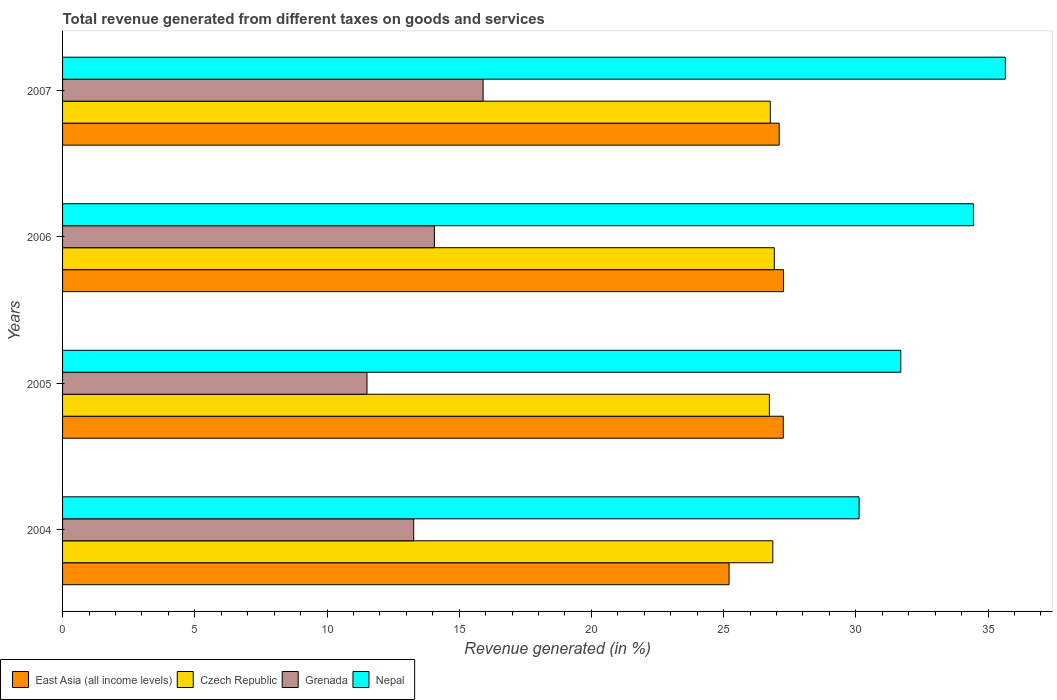Are the number of bars per tick equal to the number of legend labels?
Your answer should be compact. Yes. How many bars are there on the 3rd tick from the bottom?
Your answer should be compact. 4. What is the label of the 3rd group of bars from the top?
Ensure brevity in your answer.  2005. In how many cases, is the number of bars for a given year not equal to the number of legend labels?
Ensure brevity in your answer.  0. What is the total revenue generated in East Asia (all income levels) in 2006?
Your response must be concise. 27.26. Across all years, what is the maximum total revenue generated in East Asia (all income levels)?
Your answer should be compact. 27.26. Across all years, what is the minimum total revenue generated in Czech Republic?
Provide a succinct answer. 26.73. In which year was the total revenue generated in Grenada minimum?
Provide a short and direct response. 2005. What is the total total revenue generated in Grenada in the graph?
Make the answer very short. 54.76. What is the difference between the total revenue generated in Czech Republic in 2004 and that in 2005?
Ensure brevity in your answer.  0.13. What is the difference between the total revenue generated in Czech Republic in 2004 and the total revenue generated in Nepal in 2006?
Offer a very short reply. -7.59. What is the average total revenue generated in Grenada per year?
Make the answer very short. 13.69. In the year 2006, what is the difference between the total revenue generated in Czech Republic and total revenue generated in Nepal?
Your answer should be very brief. -7.53. In how many years, is the total revenue generated in Nepal greater than 25 %?
Offer a very short reply. 4. What is the ratio of the total revenue generated in Nepal in 2005 to that in 2006?
Keep it short and to the point. 0.92. What is the difference between the highest and the second highest total revenue generated in Czech Republic?
Ensure brevity in your answer.  0.06. What is the difference between the highest and the lowest total revenue generated in Nepal?
Your response must be concise. 5.53. Is it the case that in every year, the sum of the total revenue generated in Nepal and total revenue generated in Czech Republic is greater than the sum of total revenue generated in Grenada and total revenue generated in East Asia (all income levels)?
Provide a succinct answer. No. What does the 2nd bar from the top in 2005 represents?
Give a very brief answer. Grenada. What does the 1st bar from the bottom in 2007 represents?
Ensure brevity in your answer.  East Asia (all income levels). Is it the case that in every year, the sum of the total revenue generated in Nepal and total revenue generated in Czech Republic is greater than the total revenue generated in Grenada?
Give a very brief answer. Yes. Are all the bars in the graph horizontal?
Make the answer very short. Yes. Are the values on the major ticks of X-axis written in scientific E-notation?
Your answer should be very brief. No. How many legend labels are there?
Make the answer very short. 4. What is the title of the graph?
Provide a short and direct response. Total revenue generated from different taxes on goods and services. What is the label or title of the X-axis?
Make the answer very short. Revenue generated (in %). What is the Revenue generated (in %) in East Asia (all income levels) in 2004?
Your response must be concise. 25.2. What is the Revenue generated (in %) in Czech Republic in 2004?
Make the answer very short. 26.86. What is the Revenue generated (in %) in Grenada in 2004?
Provide a short and direct response. 13.28. What is the Revenue generated (in %) in Nepal in 2004?
Your answer should be compact. 30.12. What is the Revenue generated (in %) of East Asia (all income levels) in 2005?
Your answer should be very brief. 27.26. What is the Revenue generated (in %) of Czech Republic in 2005?
Provide a short and direct response. 26.73. What is the Revenue generated (in %) in Grenada in 2005?
Offer a very short reply. 11.51. What is the Revenue generated (in %) of Nepal in 2005?
Your answer should be compact. 31.7. What is the Revenue generated (in %) in East Asia (all income levels) in 2006?
Offer a very short reply. 27.26. What is the Revenue generated (in %) in Czech Republic in 2006?
Your answer should be compact. 26.92. What is the Revenue generated (in %) of Grenada in 2006?
Your response must be concise. 14.06. What is the Revenue generated (in %) in Nepal in 2006?
Your answer should be very brief. 34.45. What is the Revenue generated (in %) in East Asia (all income levels) in 2007?
Your answer should be compact. 27.1. What is the Revenue generated (in %) in Czech Republic in 2007?
Your answer should be very brief. 26.76. What is the Revenue generated (in %) of Grenada in 2007?
Your answer should be very brief. 15.9. What is the Revenue generated (in %) in Nepal in 2007?
Your answer should be very brief. 35.65. Across all years, what is the maximum Revenue generated (in %) in East Asia (all income levels)?
Keep it short and to the point. 27.26. Across all years, what is the maximum Revenue generated (in %) of Czech Republic?
Offer a very short reply. 26.92. Across all years, what is the maximum Revenue generated (in %) in Grenada?
Offer a very short reply. 15.9. Across all years, what is the maximum Revenue generated (in %) in Nepal?
Your response must be concise. 35.65. Across all years, what is the minimum Revenue generated (in %) of East Asia (all income levels)?
Offer a terse response. 25.2. Across all years, what is the minimum Revenue generated (in %) in Czech Republic?
Your answer should be very brief. 26.73. Across all years, what is the minimum Revenue generated (in %) of Grenada?
Keep it short and to the point. 11.51. Across all years, what is the minimum Revenue generated (in %) in Nepal?
Your response must be concise. 30.12. What is the total Revenue generated (in %) of East Asia (all income levels) in the graph?
Provide a succinct answer. 106.82. What is the total Revenue generated (in %) in Czech Republic in the graph?
Make the answer very short. 107.27. What is the total Revenue generated (in %) of Grenada in the graph?
Offer a terse response. 54.76. What is the total Revenue generated (in %) in Nepal in the graph?
Your response must be concise. 131.92. What is the difference between the Revenue generated (in %) of East Asia (all income levels) in 2004 and that in 2005?
Ensure brevity in your answer.  -2.05. What is the difference between the Revenue generated (in %) in Czech Republic in 2004 and that in 2005?
Make the answer very short. 0.13. What is the difference between the Revenue generated (in %) of Grenada in 2004 and that in 2005?
Ensure brevity in your answer.  1.77. What is the difference between the Revenue generated (in %) in Nepal in 2004 and that in 2005?
Provide a succinct answer. -1.58. What is the difference between the Revenue generated (in %) of East Asia (all income levels) in 2004 and that in 2006?
Your answer should be compact. -2.06. What is the difference between the Revenue generated (in %) in Czech Republic in 2004 and that in 2006?
Your response must be concise. -0.06. What is the difference between the Revenue generated (in %) of Grenada in 2004 and that in 2006?
Provide a short and direct response. -0.78. What is the difference between the Revenue generated (in %) in Nepal in 2004 and that in 2006?
Provide a short and direct response. -4.32. What is the difference between the Revenue generated (in %) in East Asia (all income levels) in 2004 and that in 2007?
Ensure brevity in your answer.  -1.9. What is the difference between the Revenue generated (in %) in Czech Republic in 2004 and that in 2007?
Provide a succinct answer. 0.1. What is the difference between the Revenue generated (in %) of Grenada in 2004 and that in 2007?
Give a very brief answer. -2.63. What is the difference between the Revenue generated (in %) of Nepal in 2004 and that in 2007?
Provide a short and direct response. -5.53. What is the difference between the Revenue generated (in %) of East Asia (all income levels) in 2005 and that in 2006?
Provide a succinct answer. -0.01. What is the difference between the Revenue generated (in %) in Czech Republic in 2005 and that in 2006?
Provide a short and direct response. -0.19. What is the difference between the Revenue generated (in %) of Grenada in 2005 and that in 2006?
Provide a short and direct response. -2.55. What is the difference between the Revenue generated (in %) of Nepal in 2005 and that in 2006?
Offer a terse response. -2.75. What is the difference between the Revenue generated (in %) in East Asia (all income levels) in 2005 and that in 2007?
Your answer should be very brief. 0.16. What is the difference between the Revenue generated (in %) in Czech Republic in 2005 and that in 2007?
Provide a succinct answer. -0.03. What is the difference between the Revenue generated (in %) of Grenada in 2005 and that in 2007?
Offer a very short reply. -4.39. What is the difference between the Revenue generated (in %) in Nepal in 2005 and that in 2007?
Ensure brevity in your answer.  -3.95. What is the difference between the Revenue generated (in %) in East Asia (all income levels) in 2006 and that in 2007?
Your answer should be compact. 0.16. What is the difference between the Revenue generated (in %) of Czech Republic in 2006 and that in 2007?
Give a very brief answer. 0.15. What is the difference between the Revenue generated (in %) in Grenada in 2006 and that in 2007?
Provide a short and direct response. -1.84. What is the difference between the Revenue generated (in %) of Nepal in 2006 and that in 2007?
Provide a short and direct response. -1.21. What is the difference between the Revenue generated (in %) of East Asia (all income levels) in 2004 and the Revenue generated (in %) of Czech Republic in 2005?
Provide a succinct answer. -1.53. What is the difference between the Revenue generated (in %) of East Asia (all income levels) in 2004 and the Revenue generated (in %) of Grenada in 2005?
Give a very brief answer. 13.69. What is the difference between the Revenue generated (in %) in East Asia (all income levels) in 2004 and the Revenue generated (in %) in Nepal in 2005?
Keep it short and to the point. -6.49. What is the difference between the Revenue generated (in %) in Czech Republic in 2004 and the Revenue generated (in %) in Grenada in 2005?
Your answer should be compact. 15.35. What is the difference between the Revenue generated (in %) of Czech Republic in 2004 and the Revenue generated (in %) of Nepal in 2005?
Ensure brevity in your answer.  -4.84. What is the difference between the Revenue generated (in %) in Grenada in 2004 and the Revenue generated (in %) in Nepal in 2005?
Offer a very short reply. -18.42. What is the difference between the Revenue generated (in %) in East Asia (all income levels) in 2004 and the Revenue generated (in %) in Czech Republic in 2006?
Offer a very short reply. -1.71. What is the difference between the Revenue generated (in %) in East Asia (all income levels) in 2004 and the Revenue generated (in %) in Grenada in 2006?
Offer a terse response. 11.14. What is the difference between the Revenue generated (in %) in East Asia (all income levels) in 2004 and the Revenue generated (in %) in Nepal in 2006?
Give a very brief answer. -9.24. What is the difference between the Revenue generated (in %) in Czech Republic in 2004 and the Revenue generated (in %) in Grenada in 2006?
Your answer should be compact. 12.8. What is the difference between the Revenue generated (in %) in Czech Republic in 2004 and the Revenue generated (in %) in Nepal in 2006?
Your answer should be compact. -7.59. What is the difference between the Revenue generated (in %) of Grenada in 2004 and the Revenue generated (in %) of Nepal in 2006?
Your answer should be very brief. -21.17. What is the difference between the Revenue generated (in %) in East Asia (all income levels) in 2004 and the Revenue generated (in %) in Czech Republic in 2007?
Your response must be concise. -1.56. What is the difference between the Revenue generated (in %) in East Asia (all income levels) in 2004 and the Revenue generated (in %) in Grenada in 2007?
Offer a terse response. 9.3. What is the difference between the Revenue generated (in %) of East Asia (all income levels) in 2004 and the Revenue generated (in %) of Nepal in 2007?
Your answer should be compact. -10.45. What is the difference between the Revenue generated (in %) of Czech Republic in 2004 and the Revenue generated (in %) of Grenada in 2007?
Provide a succinct answer. 10.96. What is the difference between the Revenue generated (in %) of Czech Republic in 2004 and the Revenue generated (in %) of Nepal in 2007?
Your response must be concise. -8.79. What is the difference between the Revenue generated (in %) in Grenada in 2004 and the Revenue generated (in %) in Nepal in 2007?
Your answer should be compact. -22.37. What is the difference between the Revenue generated (in %) of East Asia (all income levels) in 2005 and the Revenue generated (in %) of Czech Republic in 2006?
Offer a very short reply. 0.34. What is the difference between the Revenue generated (in %) in East Asia (all income levels) in 2005 and the Revenue generated (in %) in Grenada in 2006?
Provide a short and direct response. 13.19. What is the difference between the Revenue generated (in %) of East Asia (all income levels) in 2005 and the Revenue generated (in %) of Nepal in 2006?
Your response must be concise. -7.19. What is the difference between the Revenue generated (in %) of Czech Republic in 2005 and the Revenue generated (in %) of Grenada in 2006?
Give a very brief answer. 12.67. What is the difference between the Revenue generated (in %) in Czech Republic in 2005 and the Revenue generated (in %) in Nepal in 2006?
Make the answer very short. -7.72. What is the difference between the Revenue generated (in %) in Grenada in 2005 and the Revenue generated (in %) in Nepal in 2006?
Keep it short and to the point. -22.93. What is the difference between the Revenue generated (in %) in East Asia (all income levels) in 2005 and the Revenue generated (in %) in Czech Republic in 2007?
Your response must be concise. 0.49. What is the difference between the Revenue generated (in %) of East Asia (all income levels) in 2005 and the Revenue generated (in %) of Grenada in 2007?
Make the answer very short. 11.35. What is the difference between the Revenue generated (in %) of East Asia (all income levels) in 2005 and the Revenue generated (in %) of Nepal in 2007?
Your answer should be very brief. -8.4. What is the difference between the Revenue generated (in %) in Czech Republic in 2005 and the Revenue generated (in %) in Grenada in 2007?
Your response must be concise. 10.83. What is the difference between the Revenue generated (in %) of Czech Republic in 2005 and the Revenue generated (in %) of Nepal in 2007?
Offer a very short reply. -8.92. What is the difference between the Revenue generated (in %) in Grenada in 2005 and the Revenue generated (in %) in Nepal in 2007?
Offer a terse response. -24.14. What is the difference between the Revenue generated (in %) in East Asia (all income levels) in 2006 and the Revenue generated (in %) in Czech Republic in 2007?
Your answer should be very brief. 0.5. What is the difference between the Revenue generated (in %) of East Asia (all income levels) in 2006 and the Revenue generated (in %) of Grenada in 2007?
Provide a short and direct response. 11.36. What is the difference between the Revenue generated (in %) of East Asia (all income levels) in 2006 and the Revenue generated (in %) of Nepal in 2007?
Your answer should be compact. -8.39. What is the difference between the Revenue generated (in %) in Czech Republic in 2006 and the Revenue generated (in %) in Grenada in 2007?
Offer a terse response. 11.01. What is the difference between the Revenue generated (in %) in Czech Republic in 2006 and the Revenue generated (in %) in Nepal in 2007?
Keep it short and to the point. -8.74. What is the difference between the Revenue generated (in %) in Grenada in 2006 and the Revenue generated (in %) in Nepal in 2007?
Provide a succinct answer. -21.59. What is the average Revenue generated (in %) of East Asia (all income levels) per year?
Your response must be concise. 26.71. What is the average Revenue generated (in %) of Czech Republic per year?
Ensure brevity in your answer.  26.82. What is the average Revenue generated (in %) in Grenada per year?
Offer a terse response. 13.69. What is the average Revenue generated (in %) in Nepal per year?
Provide a short and direct response. 32.98. In the year 2004, what is the difference between the Revenue generated (in %) in East Asia (all income levels) and Revenue generated (in %) in Czech Republic?
Your answer should be very brief. -1.66. In the year 2004, what is the difference between the Revenue generated (in %) of East Asia (all income levels) and Revenue generated (in %) of Grenada?
Offer a very short reply. 11.93. In the year 2004, what is the difference between the Revenue generated (in %) in East Asia (all income levels) and Revenue generated (in %) in Nepal?
Offer a terse response. -4.92. In the year 2004, what is the difference between the Revenue generated (in %) of Czech Republic and Revenue generated (in %) of Grenada?
Ensure brevity in your answer.  13.58. In the year 2004, what is the difference between the Revenue generated (in %) in Czech Republic and Revenue generated (in %) in Nepal?
Your response must be concise. -3.26. In the year 2004, what is the difference between the Revenue generated (in %) of Grenada and Revenue generated (in %) of Nepal?
Offer a very short reply. -16.84. In the year 2005, what is the difference between the Revenue generated (in %) of East Asia (all income levels) and Revenue generated (in %) of Czech Republic?
Ensure brevity in your answer.  0.53. In the year 2005, what is the difference between the Revenue generated (in %) in East Asia (all income levels) and Revenue generated (in %) in Grenada?
Give a very brief answer. 15.74. In the year 2005, what is the difference between the Revenue generated (in %) in East Asia (all income levels) and Revenue generated (in %) in Nepal?
Your answer should be very brief. -4.44. In the year 2005, what is the difference between the Revenue generated (in %) in Czech Republic and Revenue generated (in %) in Grenada?
Keep it short and to the point. 15.22. In the year 2005, what is the difference between the Revenue generated (in %) of Czech Republic and Revenue generated (in %) of Nepal?
Offer a terse response. -4.97. In the year 2005, what is the difference between the Revenue generated (in %) of Grenada and Revenue generated (in %) of Nepal?
Make the answer very short. -20.19. In the year 2006, what is the difference between the Revenue generated (in %) of East Asia (all income levels) and Revenue generated (in %) of Czech Republic?
Your answer should be compact. 0.35. In the year 2006, what is the difference between the Revenue generated (in %) of East Asia (all income levels) and Revenue generated (in %) of Grenada?
Offer a very short reply. 13.2. In the year 2006, what is the difference between the Revenue generated (in %) of East Asia (all income levels) and Revenue generated (in %) of Nepal?
Your response must be concise. -7.18. In the year 2006, what is the difference between the Revenue generated (in %) in Czech Republic and Revenue generated (in %) in Grenada?
Provide a short and direct response. 12.86. In the year 2006, what is the difference between the Revenue generated (in %) in Czech Republic and Revenue generated (in %) in Nepal?
Give a very brief answer. -7.53. In the year 2006, what is the difference between the Revenue generated (in %) of Grenada and Revenue generated (in %) of Nepal?
Your answer should be compact. -20.38. In the year 2007, what is the difference between the Revenue generated (in %) of East Asia (all income levels) and Revenue generated (in %) of Czech Republic?
Offer a very short reply. 0.34. In the year 2007, what is the difference between the Revenue generated (in %) of East Asia (all income levels) and Revenue generated (in %) of Grenada?
Provide a short and direct response. 11.2. In the year 2007, what is the difference between the Revenue generated (in %) in East Asia (all income levels) and Revenue generated (in %) in Nepal?
Offer a terse response. -8.55. In the year 2007, what is the difference between the Revenue generated (in %) in Czech Republic and Revenue generated (in %) in Grenada?
Ensure brevity in your answer.  10.86. In the year 2007, what is the difference between the Revenue generated (in %) in Czech Republic and Revenue generated (in %) in Nepal?
Offer a very short reply. -8.89. In the year 2007, what is the difference between the Revenue generated (in %) of Grenada and Revenue generated (in %) of Nepal?
Make the answer very short. -19.75. What is the ratio of the Revenue generated (in %) in East Asia (all income levels) in 2004 to that in 2005?
Offer a terse response. 0.92. What is the ratio of the Revenue generated (in %) in Czech Republic in 2004 to that in 2005?
Offer a terse response. 1. What is the ratio of the Revenue generated (in %) of Grenada in 2004 to that in 2005?
Offer a terse response. 1.15. What is the ratio of the Revenue generated (in %) in Nepal in 2004 to that in 2005?
Your response must be concise. 0.95. What is the ratio of the Revenue generated (in %) in East Asia (all income levels) in 2004 to that in 2006?
Make the answer very short. 0.92. What is the ratio of the Revenue generated (in %) of Grenada in 2004 to that in 2006?
Offer a terse response. 0.94. What is the ratio of the Revenue generated (in %) in Nepal in 2004 to that in 2006?
Give a very brief answer. 0.87. What is the ratio of the Revenue generated (in %) in East Asia (all income levels) in 2004 to that in 2007?
Your answer should be compact. 0.93. What is the ratio of the Revenue generated (in %) of Grenada in 2004 to that in 2007?
Ensure brevity in your answer.  0.83. What is the ratio of the Revenue generated (in %) in Nepal in 2004 to that in 2007?
Offer a very short reply. 0.84. What is the ratio of the Revenue generated (in %) of East Asia (all income levels) in 2005 to that in 2006?
Your answer should be compact. 1. What is the ratio of the Revenue generated (in %) of Czech Republic in 2005 to that in 2006?
Ensure brevity in your answer.  0.99. What is the ratio of the Revenue generated (in %) of Grenada in 2005 to that in 2006?
Keep it short and to the point. 0.82. What is the ratio of the Revenue generated (in %) of Nepal in 2005 to that in 2006?
Give a very brief answer. 0.92. What is the ratio of the Revenue generated (in %) in East Asia (all income levels) in 2005 to that in 2007?
Provide a short and direct response. 1.01. What is the ratio of the Revenue generated (in %) in Czech Republic in 2005 to that in 2007?
Make the answer very short. 1. What is the ratio of the Revenue generated (in %) of Grenada in 2005 to that in 2007?
Keep it short and to the point. 0.72. What is the ratio of the Revenue generated (in %) in Nepal in 2005 to that in 2007?
Your answer should be compact. 0.89. What is the ratio of the Revenue generated (in %) of East Asia (all income levels) in 2006 to that in 2007?
Keep it short and to the point. 1.01. What is the ratio of the Revenue generated (in %) in Czech Republic in 2006 to that in 2007?
Provide a short and direct response. 1.01. What is the ratio of the Revenue generated (in %) of Grenada in 2006 to that in 2007?
Ensure brevity in your answer.  0.88. What is the ratio of the Revenue generated (in %) of Nepal in 2006 to that in 2007?
Your answer should be compact. 0.97. What is the difference between the highest and the second highest Revenue generated (in %) of East Asia (all income levels)?
Ensure brevity in your answer.  0.01. What is the difference between the highest and the second highest Revenue generated (in %) in Czech Republic?
Provide a short and direct response. 0.06. What is the difference between the highest and the second highest Revenue generated (in %) of Grenada?
Ensure brevity in your answer.  1.84. What is the difference between the highest and the second highest Revenue generated (in %) of Nepal?
Your response must be concise. 1.21. What is the difference between the highest and the lowest Revenue generated (in %) of East Asia (all income levels)?
Your answer should be very brief. 2.06. What is the difference between the highest and the lowest Revenue generated (in %) in Czech Republic?
Your answer should be compact. 0.19. What is the difference between the highest and the lowest Revenue generated (in %) in Grenada?
Offer a very short reply. 4.39. What is the difference between the highest and the lowest Revenue generated (in %) in Nepal?
Offer a very short reply. 5.53. 